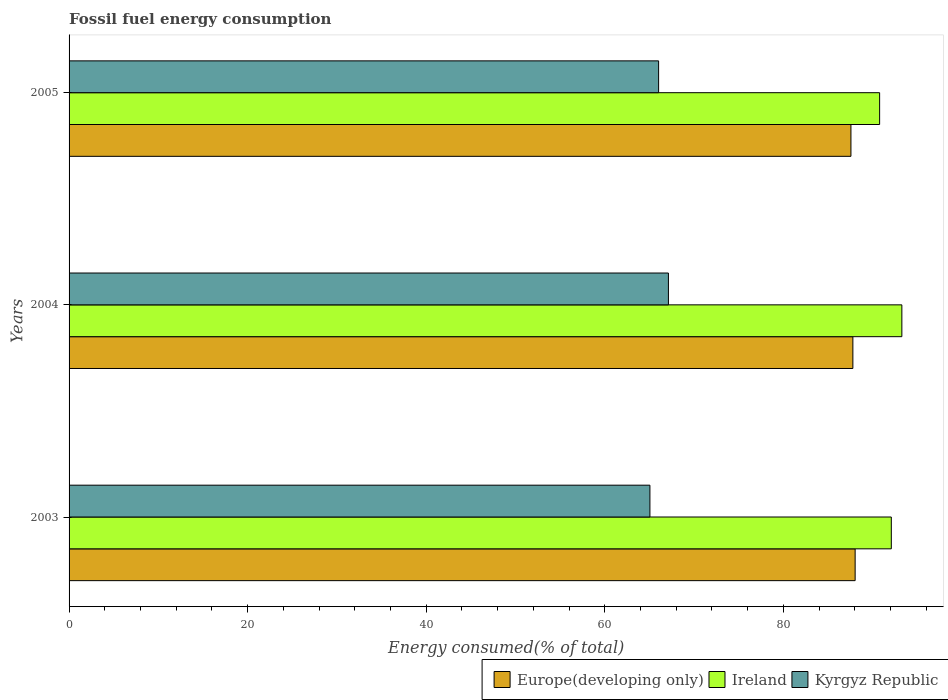How many different coloured bars are there?
Offer a terse response. 3. How many groups of bars are there?
Provide a succinct answer. 3. How many bars are there on the 3rd tick from the top?
Make the answer very short. 3. How many bars are there on the 2nd tick from the bottom?
Ensure brevity in your answer.  3. In how many cases, is the number of bars for a given year not equal to the number of legend labels?
Your answer should be compact. 0. What is the percentage of energy consumed in Kyrgyz Republic in 2003?
Your response must be concise. 65.05. Across all years, what is the maximum percentage of energy consumed in Europe(developing only)?
Offer a very short reply. 88.03. Across all years, what is the minimum percentage of energy consumed in Europe(developing only)?
Provide a short and direct response. 87.56. In which year was the percentage of energy consumed in Europe(developing only) maximum?
Provide a succinct answer. 2003. In which year was the percentage of energy consumed in Europe(developing only) minimum?
Ensure brevity in your answer.  2005. What is the total percentage of energy consumed in Europe(developing only) in the graph?
Make the answer very short. 263.37. What is the difference between the percentage of energy consumed in Europe(developing only) in 2003 and that in 2004?
Give a very brief answer. 0.25. What is the difference between the percentage of energy consumed in Kyrgyz Republic in 2004 and the percentage of energy consumed in Europe(developing only) in 2005?
Provide a short and direct response. -20.44. What is the average percentage of energy consumed in Ireland per year?
Give a very brief answer. 92.04. In the year 2005, what is the difference between the percentage of energy consumed in Ireland and percentage of energy consumed in Kyrgyz Republic?
Ensure brevity in your answer.  24.75. In how many years, is the percentage of energy consumed in Ireland greater than 68 %?
Offer a very short reply. 3. What is the ratio of the percentage of energy consumed in Europe(developing only) in 2004 to that in 2005?
Your answer should be very brief. 1. Is the percentage of energy consumed in Europe(developing only) in 2004 less than that in 2005?
Offer a terse response. No. Is the difference between the percentage of energy consumed in Ireland in 2004 and 2005 greater than the difference between the percentage of energy consumed in Kyrgyz Republic in 2004 and 2005?
Offer a very short reply. Yes. What is the difference between the highest and the second highest percentage of energy consumed in Kyrgyz Republic?
Provide a succinct answer. 1.1. What is the difference between the highest and the lowest percentage of energy consumed in Ireland?
Ensure brevity in your answer.  2.49. In how many years, is the percentage of energy consumed in Ireland greater than the average percentage of energy consumed in Ireland taken over all years?
Give a very brief answer. 2. Is the sum of the percentage of energy consumed in Kyrgyz Republic in 2003 and 2004 greater than the maximum percentage of energy consumed in Ireland across all years?
Your answer should be compact. Yes. What does the 1st bar from the top in 2004 represents?
Give a very brief answer. Kyrgyz Republic. What does the 2nd bar from the bottom in 2003 represents?
Give a very brief answer. Ireland. Is it the case that in every year, the sum of the percentage of energy consumed in Europe(developing only) and percentage of energy consumed in Kyrgyz Republic is greater than the percentage of energy consumed in Ireland?
Offer a very short reply. Yes. Are all the bars in the graph horizontal?
Your answer should be very brief. Yes. Are the values on the major ticks of X-axis written in scientific E-notation?
Your answer should be very brief. No. Does the graph contain any zero values?
Make the answer very short. No. How many legend labels are there?
Give a very brief answer. 3. What is the title of the graph?
Offer a very short reply. Fossil fuel energy consumption. What is the label or title of the X-axis?
Keep it short and to the point. Energy consumed(% of total). What is the label or title of the Y-axis?
Provide a succinct answer. Years. What is the Energy consumed(% of total) in Europe(developing only) in 2003?
Offer a terse response. 88.03. What is the Energy consumed(% of total) of Ireland in 2003?
Keep it short and to the point. 92.08. What is the Energy consumed(% of total) of Kyrgyz Republic in 2003?
Offer a terse response. 65.05. What is the Energy consumed(% of total) in Europe(developing only) in 2004?
Make the answer very short. 87.78. What is the Energy consumed(% of total) of Ireland in 2004?
Provide a succinct answer. 93.26. What is the Energy consumed(% of total) of Kyrgyz Republic in 2004?
Offer a very short reply. 67.12. What is the Energy consumed(% of total) of Europe(developing only) in 2005?
Your response must be concise. 87.56. What is the Energy consumed(% of total) in Ireland in 2005?
Keep it short and to the point. 90.77. What is the Energy consumed(% of total) in Kyrgyz Republic in 2005?
Make the answer very short. 66.02. Across all years, what is the maximum Energy consumed(% of total) of Europe(developing only)?
Your response must be concise. 88.03. Across all years, what is the maximum Energy consumed(% of total) in Ireland?
Offer a terse response. 93.26. Across all years, what is the maximum Energy consumed(% of total) of Kyrgyz Republic?
Keep it short and to the point. 67.12. Across all years, what is the minimum Energy consumed(% of total) in Europe(developing only)?
Your answer should be very brief. 87.56. Across all years, what is the minimum Energy consumed(% of total) of Ireland?
Make the answer very short. 90.77. Across all years, what is the minimum Energy consumed(% of total) in Kyrgyz Republic?
Give a very brief answer. 65.05. What is the total Energy consumed(% of total) in Europe(developing only) in the graph?
Make the answer very short. 263.37. What is the total Energy consumed(% of total) in Ireland in the graph?
Ensure brevity in your answer.  276.12. What is the total Energy consumed(% of total) of Kyrgyz Republic in the graph?
Make the answer very short. 198.19. What is the difference between the Energy consumed(% of total) of Europe(developing only) in 2003 and that in 2004?
Make the answer very short. 0.25. What is the difference between the Energy consumed(% of total) of Ireland in 2003 and that in 2004?
Your answer should be very brief. -1.18. What is the difference between the Energy consumed(% of total) of Kyrgyz Republic in 2003 and that in 2004?
Keep it short and to the point. -2.07. What is the difference between the Energy consumed(% of total) of Europe(developing only) in 2003 and that in 2005?
Your answer should be compact. 0.47. What is the difference between the Energy consumed(% of total) of Ireland in 2003 and that in 2005?
Offer a terse response. 1.31. What is the difference between the Energy consumed(% of total) of Kyrgyz Republic in 2003 and that in 2005?
Your answer should be very brief. -0.97. What is the difference between the Energy consumed(% of total) in Europe(developing only) in 2004 and that in 2005?
Keep it short and to the point. 0.22. What is the difference between the Energy consumed(% of total) in Ireland in 2004 and that in 2005?
Offer a very short reply. 2.49. What is the difference between the Energy consumed(% of total) of Kyrgyz Republic in 2004 and that in 2005?
Your answer should be very brief. 1.1. What is the difference between the Energy consumed(% of total) in Europe(developing only) in 2003 and the Energy consumed(% of total) in Ireland in 2004?
Make the answer very short. -5.23. What is the difference between the Energy consumed(% of total) in Europe(developing only) in 2003 and the Energy consumed(% of total) in Kyrgyz Republic in 2004?
Your response must be concise. 20.91. What is the difference between the Energy consumed(% of total) in Ireland in 2003 and the Energy consumed(% of total) in Kyrgyz Republic in 2004?
Provide a short and direct response. 24.96. What is the difference between the Energy consumed(% of total) in Europe(developing only) in 2003 and the Energy consumed(% of total) in Ireland in 2005?
Provide a succinct answer. -2.74. What is the difference between the Energy consumed(% of total) in Europe(developing only) in 2003 and the Energy consumed(% of total) in Kyrgyz Republic in 2005?
Keep it short and to the point. 22.01. What is the difference between the Energy consumed(% of total) of Ireland in 2003 and the Energy consumed(% of total) of Kyrgyz Republic in 2005?
Your response must be concise. 26.06. What is the difference between the Energy consumed(% of total) in Europe(developing only) in 2004 and the Energy consumed(% of total) in Ireland in 2005?
Offer a very short reply. -2.99. What is the difference between the Energy consumed(% of total) of Europe(developing only) in 2004 and the Energy consumed(% of total) of Kyrgyz Republic in 2005?
Your answer should be compact. 21.76. What is the difference between the Energy consumed(% of total) in Ireland in 2004 and the Energy consumed(% of total) in Kyrgyz Republic in 2005?
Provide a succinct answer. 27.24. What is the average Energy consumed(% of total) in Europe(developing only) per year?
Your answer should be compact. 87.79. What is the average Energy consumed(% of total) of Ireland per year?
Your answer should be very brief. 92.04. What is the average Energy consumed(% of total) of Kyrgyz Republic per year?
Keep it short and to the point. 66.06. In the year 2003, what is the difference between the Energy consumed(% of total) in Europe(developing only) and Energy consumed(% of total) in Ireland?
Give a very brief answer. -4.05. In the year 2003, what is the difference between the Energy consumed(% of total) of Europe(developing only) and Energy consumed(% of total) of Kyrgyz Republic?
Your answer should be very brief. 22.98. In the year 2003, what is the difference between the Energy consumed(% of total) in Ireland and Energy consumed(% of total) in Kyrgyz Republic?
Your answer should be very brief. 27.03. In the year 2004, what is the difference between the Energy consumed(% of total) of Europe(developing only) and Energy consumed(% of total) of Ireland?
Make the answer very short. -5.48. In the year 2004, what is the difference between the Energy consumed(% of total) in Europe(developing only) and Energy consumed(% of total) in Kyrgyz Republic?
Your response must be concise. 20.66. In the year 2004, what is the difference between the Energy consumed(% of total) of Ireland and Energy consumed(% of total) of Kyrgyz Republic?
Your answer should be compact. 26.14. In the year 2005, what is the difference between the Energy consumed(% of total) of Europe(developing only) and Energy consumed(% of total) of Ireland?
Keep it short and to the point. -3.21. In the year 2005, what is the difference between the Energy consumed(% of total) in Europe(developing only) and Energy consumed(% of total) in Kyrgyz Republic?
Your answer should be very brief. 21.54. In the year 2005, what is the difference between the Energy consumed(% of total) in Ireland and Energy consumed(% of total) in Kyrgyz Republic?
Your answer should be compact. 24.75. What is the ratio of the Energy consumed(% of total) in Ireland in 2003 to that in 2004?
Offer a terse response. 0.99. What is the ratio of the Energy consumed(% of total) in Kyrgyz Republic in 2003 to that in 2004?
Offer a terse response. 0.97. What is the ratio of the Energy consumed(% of total) in Europe(developing only) in 2003 to that in 2005?
Keep it short and to the point. 1.01. What is the ratio of the Energy consumed(% of total) of Ireland in 2003 to that in 2005?
Give a very brief answer. 1.01. What is the ratio of the Energy consumed(% of total) of Ireland in 2004 to that in 2005?
Keep it short and to the point. 1.03. What is the ratio of the Energy consumed(% of total) of Kyrgyz Republic in 2004 to that in 2005?
Offer a terse response. 1.02. What is the difference between the highest and the second highest Energy consumed(% of total) in Europe(developing only)?
Keep it short and to the point. 0.25. What is the difference between the highest and the second highest Energy consumed(% of total) in Ireland?
Provide a short and direct response. 1.18. What is the difference between the highest and the second highest Energy consumed(% of total) of Kyrgyz Republic?
Provide a succinct answer. 1.1. What is the difference between the highest and the lowest Energy consumed(% of total) of Europe(developing only)?
Provide a succinct answer. 0.47. What is the difference between the highest and the lowest Energy consumed(% of total) in Ireland?
Give a very brief answer. 2.49. What is the difference between the highest and the lowest Energy consumed(% of total) of Kyrgyz Republic?
Offer a terse response. 2.07. 